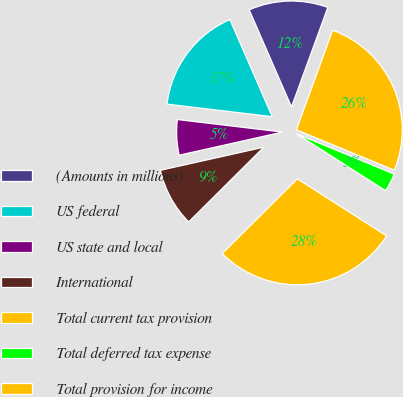Convert chart to OTSL. <chart><loc_0><loc_0><loc_500><loc_500><pie_chart><fcel>(Amounts in millions)<fcel>US federal<fcel>US state and local<fcel>International<fcel>Total current tax provision<fcel>Total deferred tax expense<fcel>Total provision for income<nl><fcel>12.11%<fcel>16.57%<fcel>5.39%<fcel>8.96%<fcel>28.49%<fcel>2.82%<fcel>25.67%<nl></chart> 